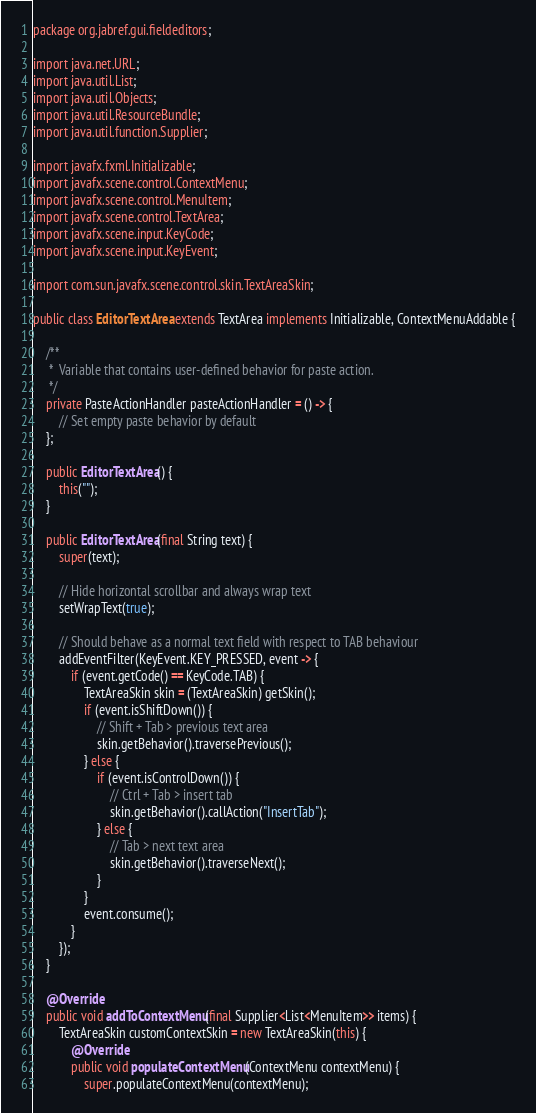Convert code to text. <code><loc_0><loc_0><loc_500><loc_500><_Java_>package org.jabref.gui.fieldeditors;

import java.net.URL;
import java.util.List;
import java.util.Objects;
import java.util.ResourceBundle;
import java.util.function.Supplier;

import javafx.fxml.Initializable;
import javafx.scene.control.ContextMenu;
import javafx.scene.control.MenuItem;
import javafx.scene.control.TextArea;
import javafx.scene.input.KeyCode;
import javafx.scene.input.KeyEvent;

import com.sun.javafx.scene.control.skin.TextAreaSkin;

public class EditorTextArea extends TextArea implements Initializable, ContextMenuAddable {

    /**
     *  Variable that contains user-defined behavior for paste action.
     */
    private PasteActionHandler pasteActionHandler = () -> {
        // Set empty paste behavior by default
    };

    public EditorTextArea() {
        this("");
    }

    public EditorTextArea(final String text) {
        super(text);

        // Hide horizontal scrollbar and always wrap text
        setWrapText(true);

        // Should behave as a normal text field with respect to TAB behaviour
        addEventFilter(KeyEvent.KEY_PRESSED, event -> {
            if (event.getCode() == KeyCode.TAB) {
                TextAreaSkin skin = (TextAreaSkin) getSkin();
                if (event.isShiftDown()) {
                    // Shift + Tab > previous text area
                    skin.getBehavior().traversePrevious();
                } else {
                    if (event.isControlDown()) {
                        // Ctrl + Tab > insert tab
                        skin.getBehavior().callAction("InsertTab");
                    } else {
                        // Tab > next text area
                        skin.getBehavior().traverseNext();
                    }
                }
                event.consume();
            }
        });
    }

    @Override
    public void addToContextMenu(final Supplier<List<MenuItem>> items) {
        TextAreaSkin customContextSkin = new TextAreaSkin(this) {
            @Override
            public void populateContextMenu(ContextMenu contextMenu) {
                super.populateContextMenu(contextMenu);</code> 